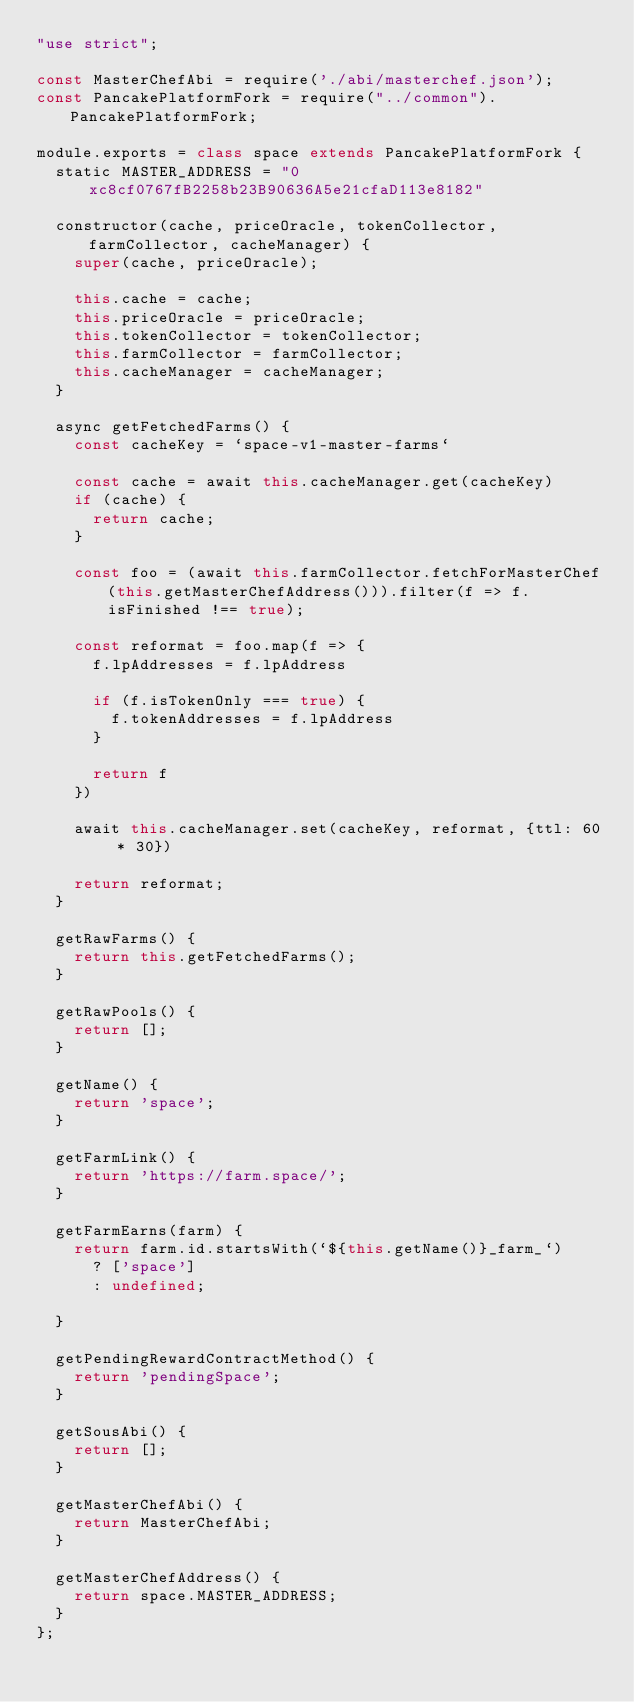Convert code to text. <code><loc_0><loc_0><loc_500><loc_500><_JavaScript_>"use strict";

const MasterChefAbi = require('./abi/masterchef.json');
const PancakePlatformFork = require("../common").PancakePlatformFork;

module.exports = class space extends PancakePlatformFork {
  static MASTER_ADDRESS = "0xc8cf0767fB2258b23B90636A5e21cfaD113e8182"

  constructor(cache, priceOracle, tokenCollector, farmCollector, cacheManager) {
    super(cache, priceOracle);

    this.cache = cache;
    this.priceOracle = priceOracle;
    this.tokenCollector = tokenCollector;
    this.farmCollector = farmCollector;
    this.cacheManager = cacheManager;
  }

  async getFetchedFarms() {
    const cacheKey = `space-v1-master-farms`

    const cache = await this.cacheManager.get(cacheKey)
    if (cache) {
      return cache;
    }

    const foo = (await this.farmCollector.fetchForMasterChef(this.getMasterChefAddress())).filter(f => f.isFinished !== true);

    const reformat = foo.map(f => {
      f.lpAddresses = f.lpAddress

      if (f.isTokenOnly === true) {
        f.tokenAddresses = f.lpAddress
      }

      return f
    })

    await this.cacheManager.set(cacheKey, reformat, {ttl: 60 * 30})

    return reformat;
  }

  getRawFarms() {
    return this.getFetchedFarms();
  }

  getRawPools() {
    return [];
  }

  getName() {
    return 'space';
  }

  getFarmLink() {
    return 'https://farm.space/';
  }

  getFarmEarns(farm) {
    return farm.id.startsWith(`${this.getName()}_farm_`)
      ? ['space']
      : undefined;

  }

  getPendingRewardContractMethod() {
    return 'pendingSpace';
  }

  getSousAbi() {
    return [];
  }

  getMasterChefAbi() {
    return MasterChefAbi;
  }

  getMasterChefAddress() {
    return space.MASTER_ADDRESS;
  }
};
</code> 